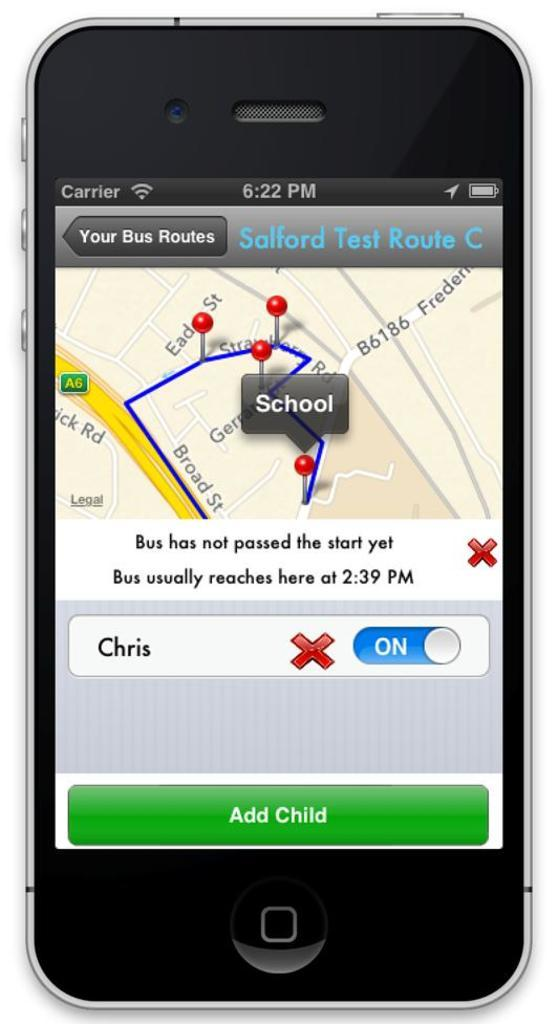<image>
Relay a brief, clear account of the picture shown. An app on a smartphone for expected bus route times. 